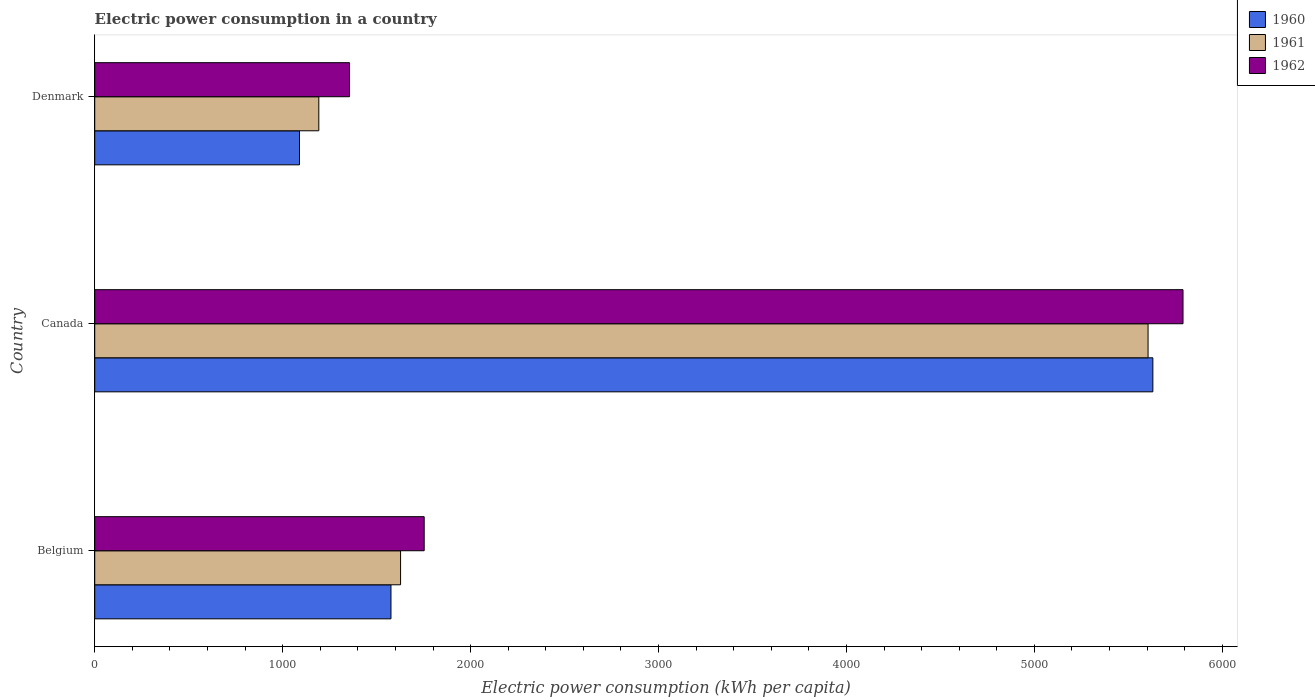How many bars are there on the 2nd tick from the bottom?
Your answer should be compact. 3. What is the label of the 3rd group of bars from the top?
Offer a very short reply. Belgium. What is the electric power consumption in in 1960 in Belgium?
Offer a very short reply. 1576.34. Across all countries, what is the maximum electric power consumption in in 1962?
Give a very brief answer. 5791.12. Across all countries, what is the minimum electric power consumption in in 1960?
Ensure brevity in your answer.  1089.61. What is the total electric power consumption in in 1961 in the graph?
Provide a succinct answer. 8425.03. What is the difference between the electric power consumption in in 1960 in Belgium and that in Canada?
Your response must be concise. -4054.29. What is the difference between the electric power consumption in in 1961 in Canada and the electric power consumption in in 1960 in Belgium?
Give a very brief answer. 4028.77. What is the average electric power consumption in in 1961 per country?
Offer a terse response. 2808.34. What is the difference between the electric power consumption in in 1961 and electric power consumption in in 1962 in Canada?
Ensure brevity in your answer.  -186.01. In how many countries, is the electric power consumption in in 1961 greater than 1400 kWh per capita?
Give a very brief answer. 2. What is the ratio of the electric power consumption in in 1960 in Canada to that in Denmark?
Your response must be concise. 5.17. What is the difference between the highest and the second highest electric power consumption in in 1962?
Your response must be concise. 4037.98. What is the difference between the highest and the lowest electric power consumption in in 1961?
Your response must be concise. 4412.71. Is it the case that in every country, the sum of the electric power consumption in in 1961 and electric power consumption in in 1960 is greater than the electric power consumption in in 1962?
Offer a terse response. Yes. How many countries are there in the graph?
Make the answer very short. 3. Where does the legend appear in the graph?
Make the answer very short. Top right. How many legend labels are there?
Offer a very short reply. 3. What is the title of the graph?
Keep it short and to the point. Electric power consumption in a country. What is the label or title of the X-axis?
Your answer should be very brief. Electric power consumption (kWh per capita). What is the Electric power consumption (kWh per capita) in 1960 in Belgium?
Your response must be concise. 1576.34. What is the Electric power consumption (kWh per capita) of 1961 in Belgium?
Your answer should be compact. 1627.51. What is the Electric power consumption (kWh per capita) of 1962 in Belgium?
Give a very brief answer. 1753.14. What is the Electric power consumption (kWh per capita) of 1960 in Canada?
Your response must be concise. 5630.63. What is the Electric power consumption (kWh per capita) in 1961 in Canada?
Provide a short and direct response. 5605.11. What is the Electric power consumption (kWh per capita) of 1962 in Canada?
Your response must be concise. 5791.12. What is the Electric power consumption (kWh per capita) of 1960 in Denmark?
Your answer should be compact. 1089.61. What is the Electric power consumption (kWh per capita) in 1961 in Denmark?
Make the answer very short. 1192.41. What is the Electric power consumption (kWh per capita) of 1962 in Denmark?
Make the answer very short. 1355.93. Across all countries, what is the maximum Electric power consumption (kWh per capita) of 1960?
Your response must be concise. 5630.63. Across all countries, what is the maximum Electric power consumption (kWh per capita) of 1961?
Provide a short and direct response. 5605.11. Across all countries, what is the maximum Electric power consumption (kWh per capita) of 1962?
Give a very brief answer. 5791.12. Across all countries, what is the minimum Electric power consumption (kWh per capita) of 1960?
Ensure brevity in your answer.  1089.61. Across all countries, what is the minimum Electric power consumption (kWh per capita) of 1961?
Provide a short and direct response. 1192.41. Across all countries, what is the minimum Electric power consumption (kWh per capita) of 1962?
Your answer should be very brief. 1355.93. What is the total Electric power consumption (kWh per capita) in 1960 in the graph?
Make the answer very short. 8296.58. What is the total Electric power consumption (kWh per capita) in 1961 in the graph?
Keep it short and to the point. 8425.03. What is the total Electric power consumption (kWh per capita) of 1962 in the graph?
Offer a very short reply. 8900.2. What is the difference between the Electric power consumption (kWh per capita) in 1960 in Belgium and that in Canada?
Offer a terse response. -4054.29. What is the difference between the Electric power consumption (kWh per capita) of 1961 in Belgium and that in Canada?
Provide a succinct answer. -3977.6. What is the difference between the Electric power consumption (kWh per capita) of 1962 in Belgium and that in Canada?
Offer a very short reply. -4037.98. What is the difference between the Electric power consumption (kWh per capita) in 1960 in Belgium and that in Denmark?
Ensure brevity in your answer.  486.72. What is the difference between the Electric power consumption (kWh per capita) of 1961 in Belgium and that in Denmark?
Provide a succinct answer. 435.11. What is the difference between the Electric power consumption (kWh per capita) in 1962 in Belgium and that in Denmark?
Your answer should be very brief. 397.21. What is the difference between the Electric power consumption (kWh per capita) of 1960 in Canada and that in Denmark?
Keep it short and to the point. 4541.02. What is the difference between the Electric power consumption (kWh per capita) in 1961 in Canada and that in Denmark?
Ensure brevity in your answer.  4412.71. What is the difference between the Electric power consumption (kWh per capita) of 1962 in Canada and that in Denmark?
Provide a short and direct response. 4435.19. What is the difference between the Electric power consumption (kWh per capita) in 1960 in Belgium and the Electric power consumption (kWh per capita) in 1961 in Canada?
Offer a terse response. -4028.77. What is the difference between the Electric power consumption (kWh per capita) of 1960 in Belgium and the Electric power consumption (kWh per capita) of 1962 in Canada?
Keep it short and to the point. -4214.79. What is the difference between the Electric power consumption (kWh per capita) in 1961 in Belgium and the Electric power consumption (kWh per capita) in 1962 in Canada?
Keep it short and to the point. -4163.61. What is the difference between the Electric power consumption (kWh per capita) in 1960 in Belgium and the Electric power consumption (kWh per capita) in 1961 in Denmark?
Your answer should be compact. 383.93. What is the difference between the Electric power consumption (kWh per capita) in 1960 in Belgium and the Electric power consumption (kWh per capita) in 1962 in Denmark?
Your answer should be compact. 220.41. What is the difference between the Electric power consumption (kWh per capita) in 1961 in Belgium and the Electric power consumption (kWh per capita) in 1962 in Denmark?
Your answer should be compact. 271.58. What is the difference between the Electric power consumption (kWh per capita) of 1960 in Canada and the Electric power consumption (kWh per capita) of 1961 in Denmark?
Ensure brevity in your answer.  4438.22. What is the difference between the Electric power consumption (kWh per capita) in 1960 in Canada and the Electric power consumption (kWh per capita) in 1962 in Denmark?
Make the answer very short. 4274.7. What is the difference between the Electric power consumption (kWh per capita) of 1961 in Canada and the Electric power consumption (kWh per capita) of 1962 in Denmark?
Your response must be concise. 4249.18. What is the average Electric power consumption (kWh per capita) in 1960 per country?
Keep it short and to the point. 2765.53. What is the average Electric power consumption (kWh per capita) in 1961 per country?
Provide a succinct answer. 2808.34. What is the average Electric power consumption (kWh per capita) in 1962 per country?
Make the answer very short. 2966.73. What is the difference between the Electric power consumption (kWh per capita) in 1960 and Electric power consumption (kWh per capita) in 1961 in Belgium?
Ensure brevity in your answer.  -51.17. What is the difference between the Electric power consumption (kWh per capita) in 1960 and Electric power consumption (kWh per capita) in 1962 in Belgium?
Offer a terse response. -176.81. What is the difference between the Electric power consumption (kWh per capita) in 1961 and Electric power consumption (kWh per capita) in 1962 in Belgium?
Make the answer very short. -125.63. What is the difference between the Electric power consumption (kWh per capita) in 1960 and Electric power consumption (kWh per capita) in 1961 in Canada?
Your response must be concise. 25.52. What is the difference between the Electric power consumption (kWh per capita) in 1960 and Electric power consumption (kWh per capita) in 1962 in Canada?
Your answer should be very brief. -160.5. What is the difference between the Electric power consumption (kWh per capita) of 1961 and Electric power consumption (kWh per capita) of 1962 in Canada?
Provide a succinct answer. -186.01. What is the difference between the Electric power consumption (kWh per capita) of 1960 and Electric power consumption (kWh per capita) of 1961 in Denmark?
Provide a short and direct response. -102.79. What is the difference between the Electric power consumption (kWh per capita) of 1960 and Electric power consumption (kWh per capita) of 1962 in Denmark?
Give a very brief answer. -266.32. What is the difference between the Electric power consumption (kWh per capita) of 1961 and Electric power consumption (kWh per capita) of 1962 in Denmark?
Keep it short and to the point. -163.53. What is the ratio of the Electric power consumption (kWh per capita) of 1960 in Belgium to that in Canada?
Offer a very short reply. 0.28. What is the ratio of the Electric power consumption (kWh per capita) in 1961 in Belgium to that in Canada?
Give a very brief answer. 0.29. What is the ratio of the Electric power consumption (kWh per capita) in 1962 in Belgium to that in Canada?
Make the answer very short. 0.3. What is the ratio of the Electric power consumption (kWh per capita) of 1960 in Belgium to that in Denmark?
Keep it short and to the point. 1.45. What is the ratio of the Electric power consumption (kWh per capita) of 1961 in Belgium to that in Denmark?
Your answer should be very brief. 1.36. What is the ratio of the Electric power consumption (kWh per capita) in 1962 in Belgium to that in Denmark?
Your response must be concise. 1.29. What is the ratio of the Electric power consumption (kWh per capita) of 1960 in Canada to that in Denmark?
Offer a very short reply. 5.17. What is the ratio of the Electric power consumption (kWh per capita) in 1961 in Canada to that in Denmark?
Provide a short and direct response. 4.7. What is the ratio of the Electric power consumption (kWh per capita) of 1962 in Canada to that in Denmark?
Your response must be concise. 4.27. What is the difference between the highest and the second highest Electric power consumption (kWh per capita) of 1960?
Offer a terse response. 4054.29. What is the difference between the highest and the second highest Electric power consumption (kWh per capita) of 1961?
Offer a terse response. 3977.6. What is the difference between the highest and the second highest Electric power consumption (kWh per capita) in 1962?
Ensure brevity in your answer.  4037.98. What is the difference between the highest and the lowest Electric power consumption (kWh per capita) of 1960?
Offer a terse response. 4541.02. What is the difference between the highest and the lowest Electric power consumption (kWh per capita) of 1961?
Your response must be concise. 4412.71. What is the difference between the highest and the lowest Electric power consumption (kWh per capita) of 1962?
Make the answer very short. 4435.19. 